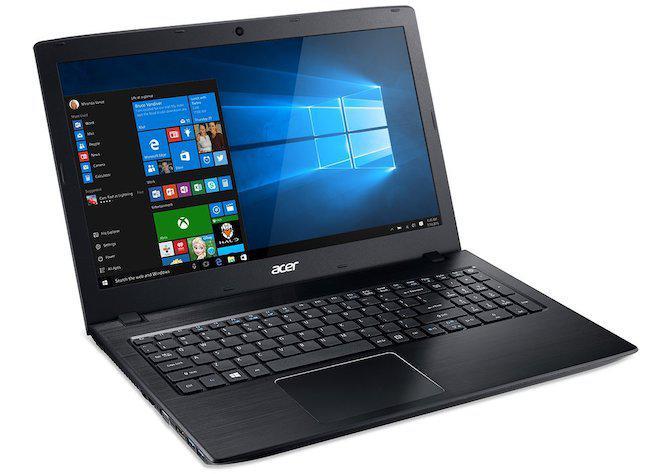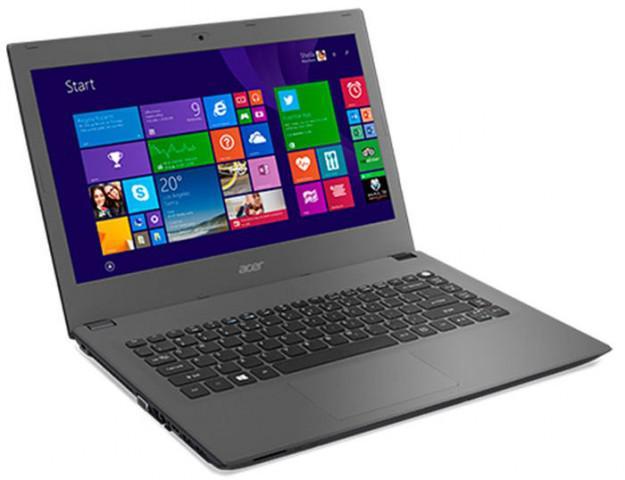The first image is the image on the left, the second image is the image on the right. Assess this claim about the two images: "All laptops are at least partly open, but only one laptop is displayed with its screen visible.". Correct or not? Answer yes or no. No. The first image is the image on the left, the second image is the image on the right. Assess this claim about the two images: "There is only one laptop screen visible out of two laptops.". Correct or not? Answer yes or no. No. 